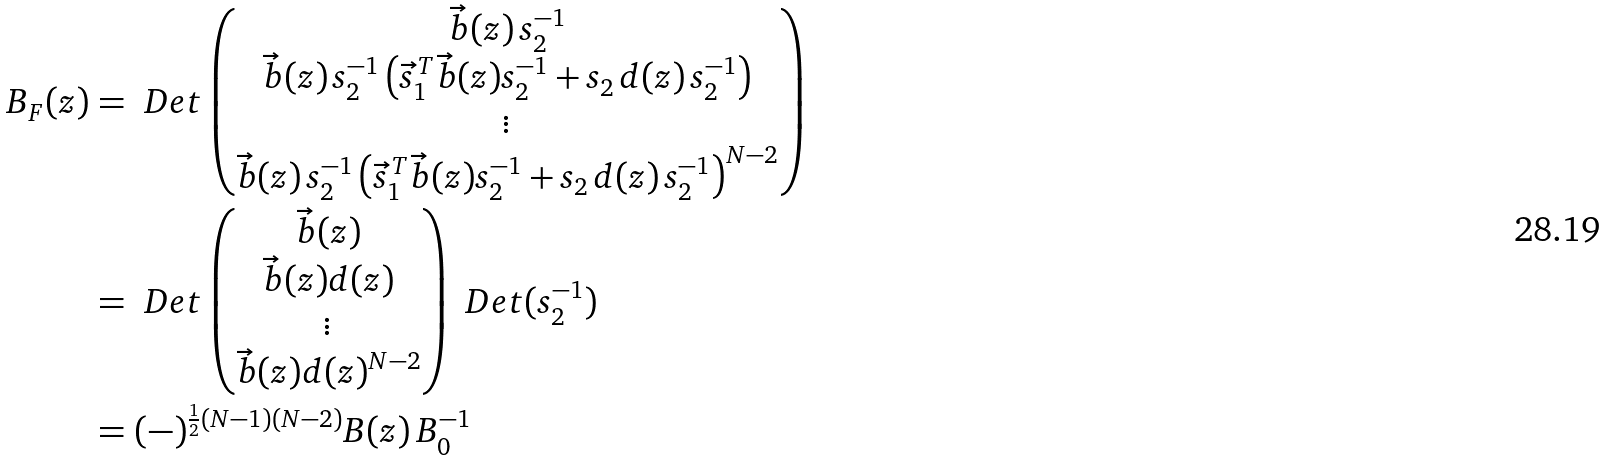<formula> <loc_0><loc_0><loc_500><loc_500>B _ { F } ( z ) & = \ D e t \begin{pmatrix} \vec { b } ( z ) \, s _ { 2 } ^ { - 1 } \\ \vec { b } ( z ) \, s _ { 2 } ^ { - 1 } \left ( { \vec { s } _ { 1 } } ^ { \, T } \vec { b } ( z ) s _ { 2 } ^ { - 1 } + s _ { 2 } \, d ( z ) \, s _ { 2 } ^ { - 1 } \right ) \\ \vdots \\ \vec { b } ( z ) \, s _ { 2 } ^ { - 1 } \left ( { \vec { s } _ { 1 } } ^ { \, T } \vec { b } ( z ) s _ { 2 } ^ { - 1 } + s _ { 2 } \, d ( z ) \, s _ { 2 } ^ { - 1 } \right ) ^ { N - 2 } \\ \end{pmatrix} \\ & = \ D e t \begin{pmatrix} \vec { b } ( z ) \\ \vec { b } ( z ) d ( z ) \\ \vdots \\ \vec { b } ( z ) d ( z ) ^ { N - 2 } \\ \end{pmatrix} \ D e t ( s _ { 2 } ^ { - 1 } ) \\ & = ( - ) ^ { \frac { 1 } { 2 } ( N - 1 ) ( N - 2 ) } B ( z ) \, B _ { 0 } ^ { - 1 }</formula> 